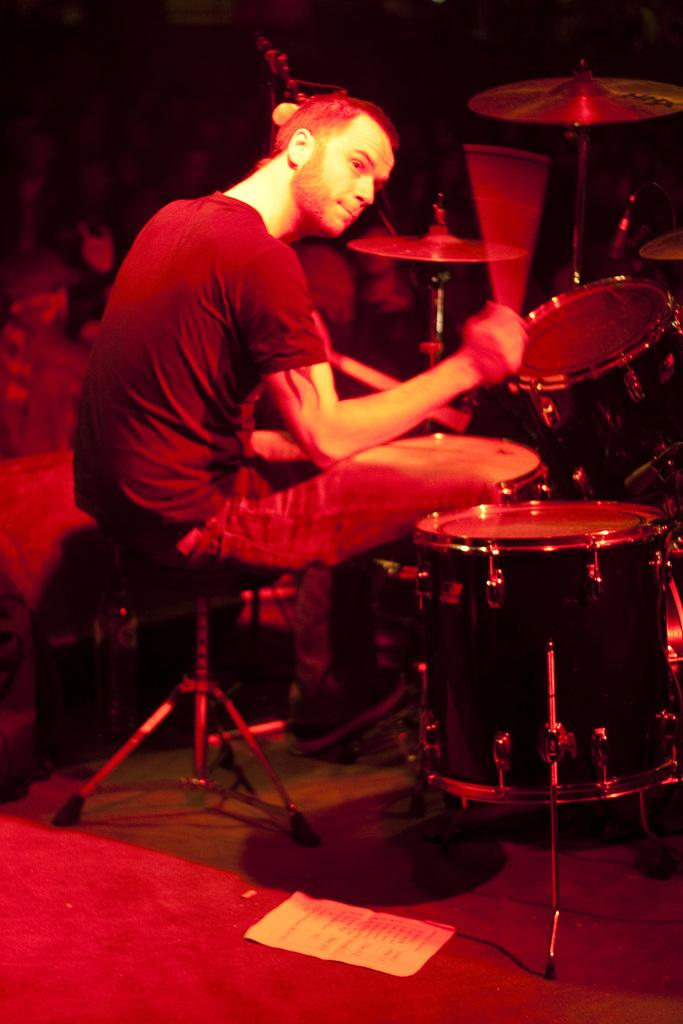What is the man in the image doing? The man is sitting on a stool in the image. What instruments are in front of the man? There are drums and cymbals in front of the man. What can be seen behind the man? There is a dark background behind the man. What object is on the ground in the image? There is a paper on the ground in the image. What type of net is being used by the man to catch the feeling in the image? There is no net or feeling present in the image; the man is sitting in front of drums and cymbals. 